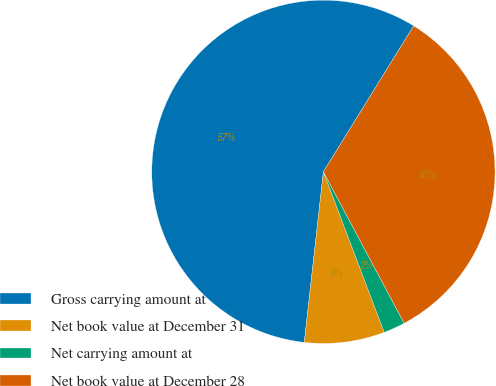Convert chart. <chart><loc_0><loc_0><loc_500><loc_500><pie_chart><fcel>Gross carrying amount at<fcel>Net book value at December 31<fcel>Net carrying amount at<fcel>Net book value at December 28<nl><fcel>57.04%<fcel>7.54%<fcel>2.04%<fcel>33.38%<nl></chart> 